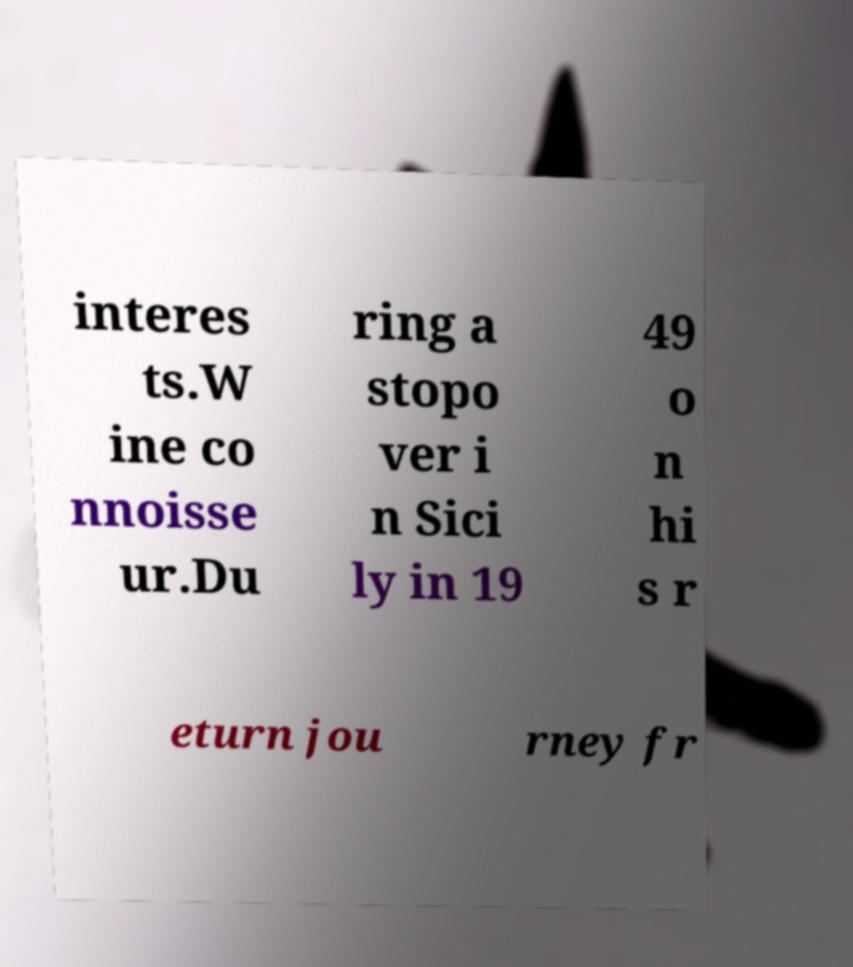There's text embedded in this image that I need extracted. Can you transcribe it verbatim? interes ts.W ine co nnoisse ur.Du ring a stopo ver i n Sici ly in 19 49 o n hi s r eturn jou rney fr 